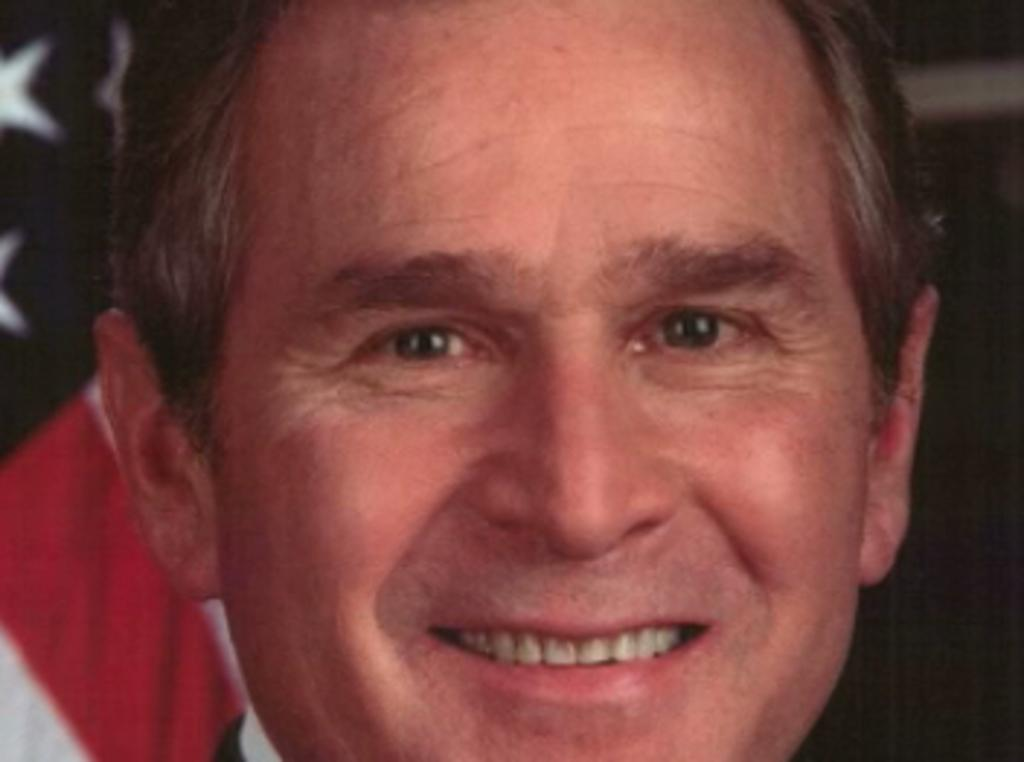What is the group of people in the image doing? The group of people in the image is sitting around a table. What activity are they engaged in? They are having a meal. Can you describe the setting of the image? The image shows a group of people sitting around a table in a location that is not specified. What direction did the group of people discover while having their meal? The transcript does not mention any discovery or direction related to the group of people having a meal. --- Facts: 1. There is a group of people in the image. 2. The people are standing together. 3. The people are holding hands. 4. There is a mountain in the background of the image. 5. There is a river in the background of the image. Absurd Topics: dance, ocean, bicycle Conversation: What is the group of people in the image doing? The group of people in the image is standing together and holding hands. Can you describe the setting of the image? The image shows a group of people standing together and holding hands in a location with a mountain and a river in the background. Reasoning: Let's think step by step in order to produce the conversation. We start by identifying the main subject in the image, which is the group of people standing together and holding hands. Then, we expand the conversation to include the setting of the image, which includes a mountain and a river in the background. Absurd Question/Answer: What type of dance is the group of people performing in the image? The transcript does not mention any dance or dancing activity related to the group of people standing together and holding hands. --- Facts: 1. There is a car in the image. 2. The car is parked on the side of the road. 3. The car is red. Absurd Topics: bird, ocean, tree Conversation: What is the main subject in the image? The main subject in the image is a car. Can you describe the car in the image? Yes, the car in the image is parked on the side of the road, and it is red. Is there any other object or element in the image besides the car? No, the image only shows a red car parked on the side of the road. Reasoning: Let's think step by step in order to produce the conversation. We start by identifying the main subject of the image, which is the car. Next, we describe specific features of the car, such as its color (red) and its location (parked on the side of the road). Finally, we acknowledge that there are no other objects or elements present in the image. Absurd Question/Answer: What type of bird can be seen sitting on the car's hood in the image? There is no bird present in the image. The image only shows a red car parked on the side of the road. 